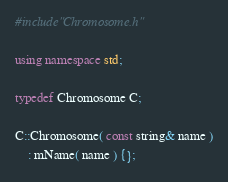<code> <loc_0><loc_0><loc_500><loc_500><_C++_>#include"Chromosome.h"

using namespace std;

typedef Chromosome C;

C::Chromosome( const string& name )
    : mName( name ) {};
</code> 